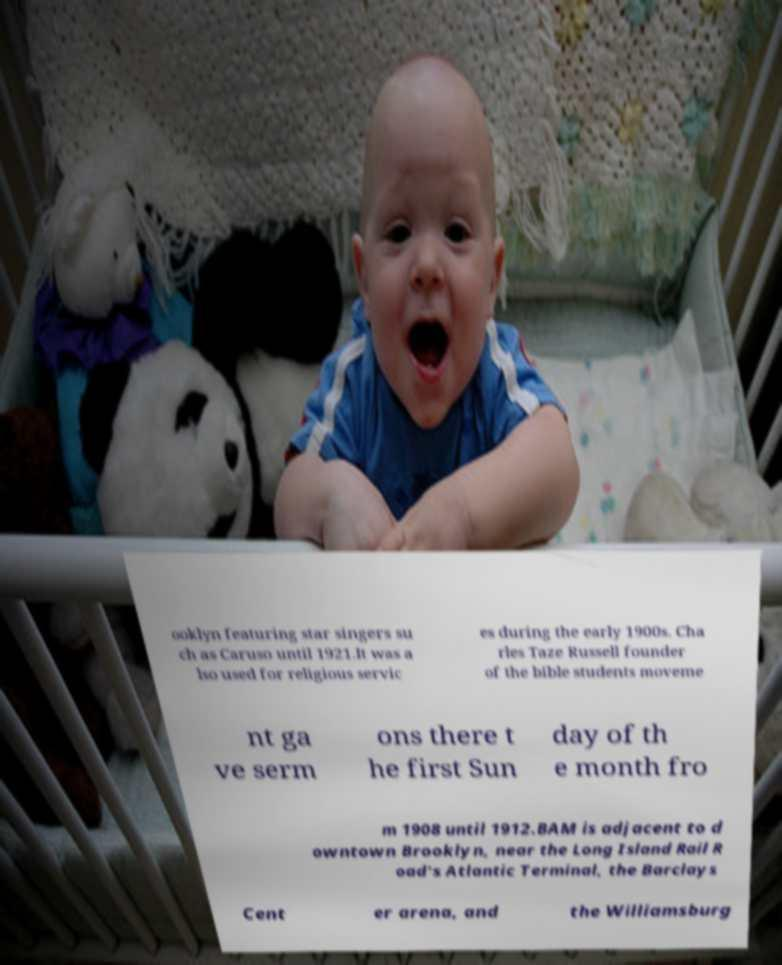Could you extract and type out the text from this image? ooklyn featuring star singers su ch as Caruso until 1921.It was a lso used for religious servic es during the early 1900s. Cha rles Taze Russell founder of the bible students moveme nt ga ve serm ons there t he first Sun day of th e month fro m 1908 until 1912.BAM is adjacent to d owntown Brooklyn, near the Long Island Rail R oad's Atlantic Terminal, the Barclays Cent er arena, and the Williamsburg 